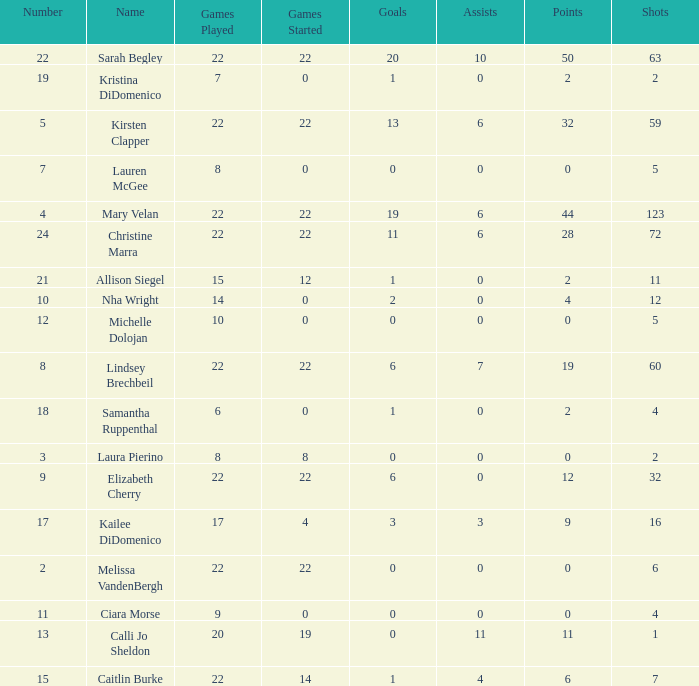How many games played catagories are there for Lauren McGee?  1.0. 